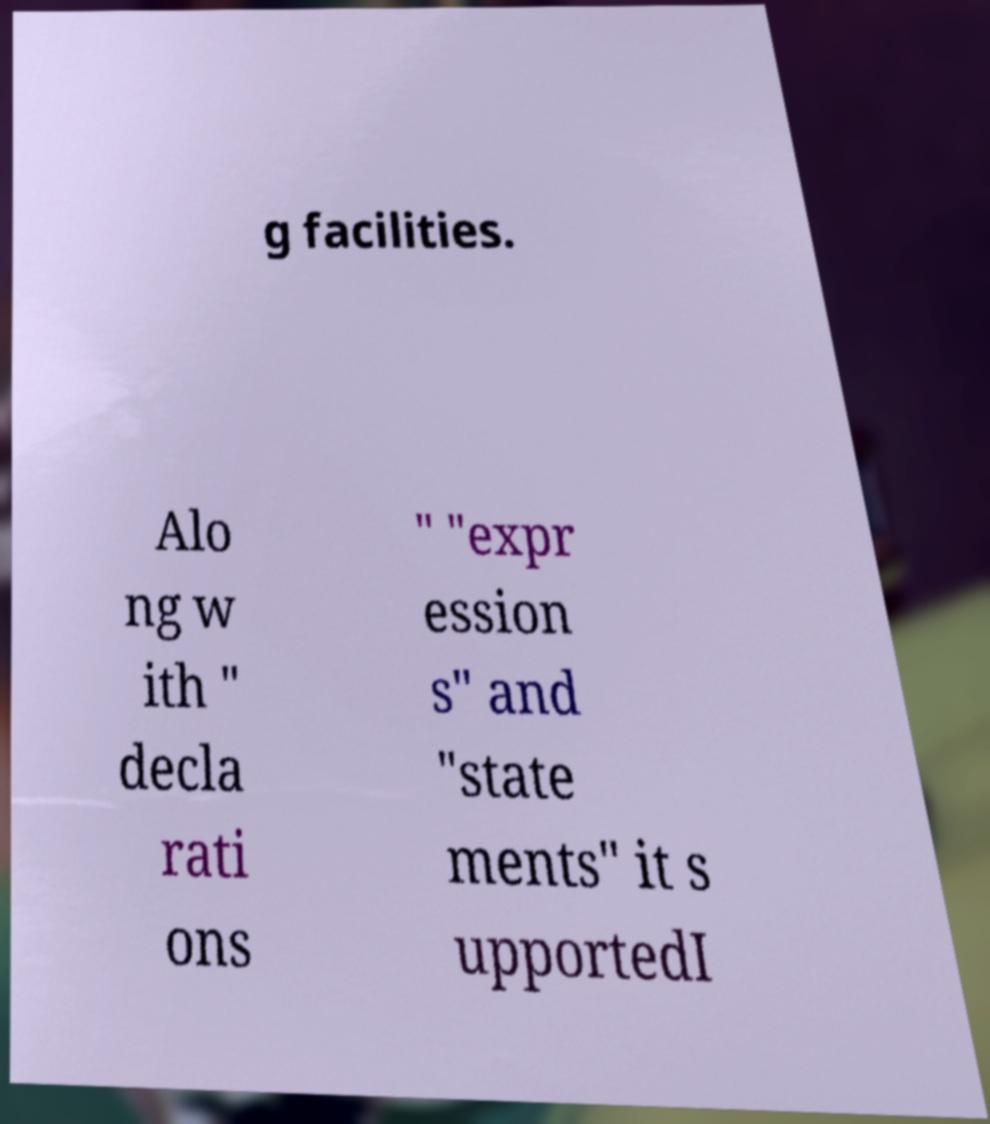There's text embedded in this image that I need extracted. Can you transcribe it verbatim? g facilities. Alo ng w ith " decla rati ons " "expr ession s" and "state ments" it s upportedI 